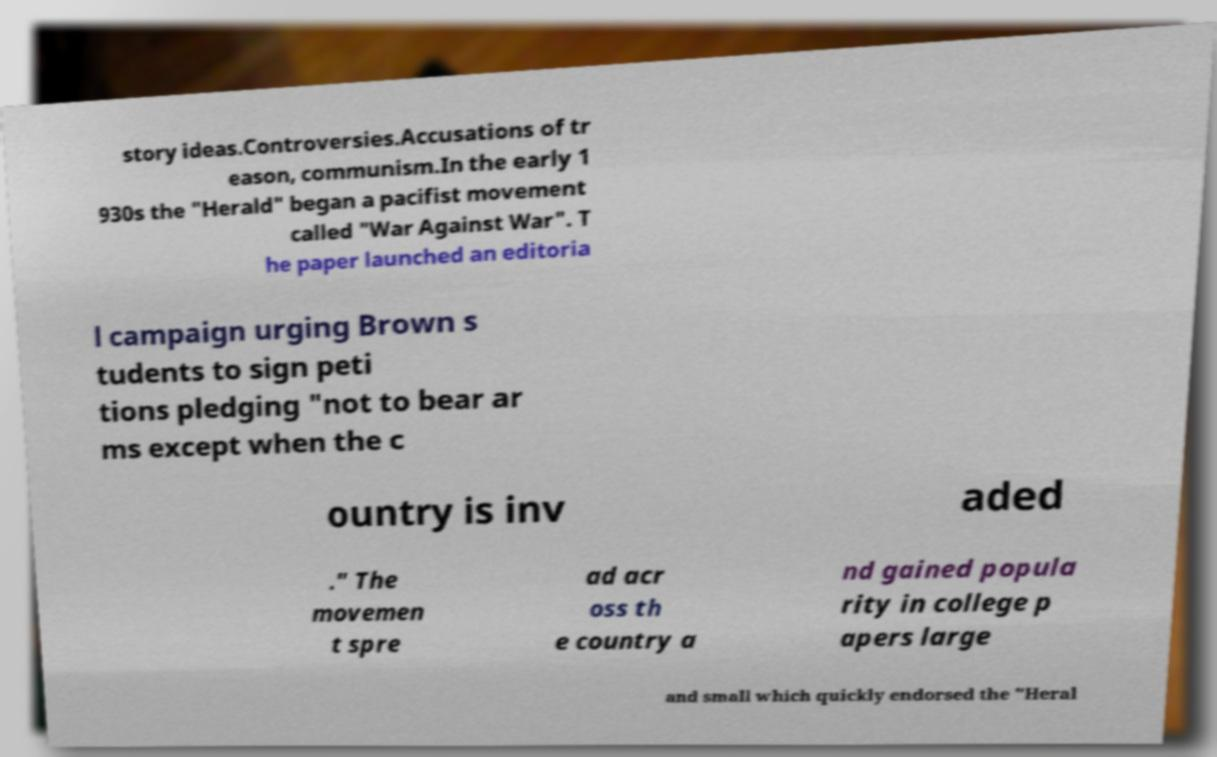Can you accurately transcribe the text from the provided image for me? story ideas.Controversies.Accusations of tr eason, communism.In the early 1 930s the "Herald" began a pacifist movement called "War Against War". T he paper launched an editoria l campaign urging Brown s tudents to sign peti tions pledging "not to bear ar ms except when the c ountry is inv aded ." The movemen t spre ad acr oss th e country a nd gained popula rity in college p apers large and small which quickly endorsed the "Heral 